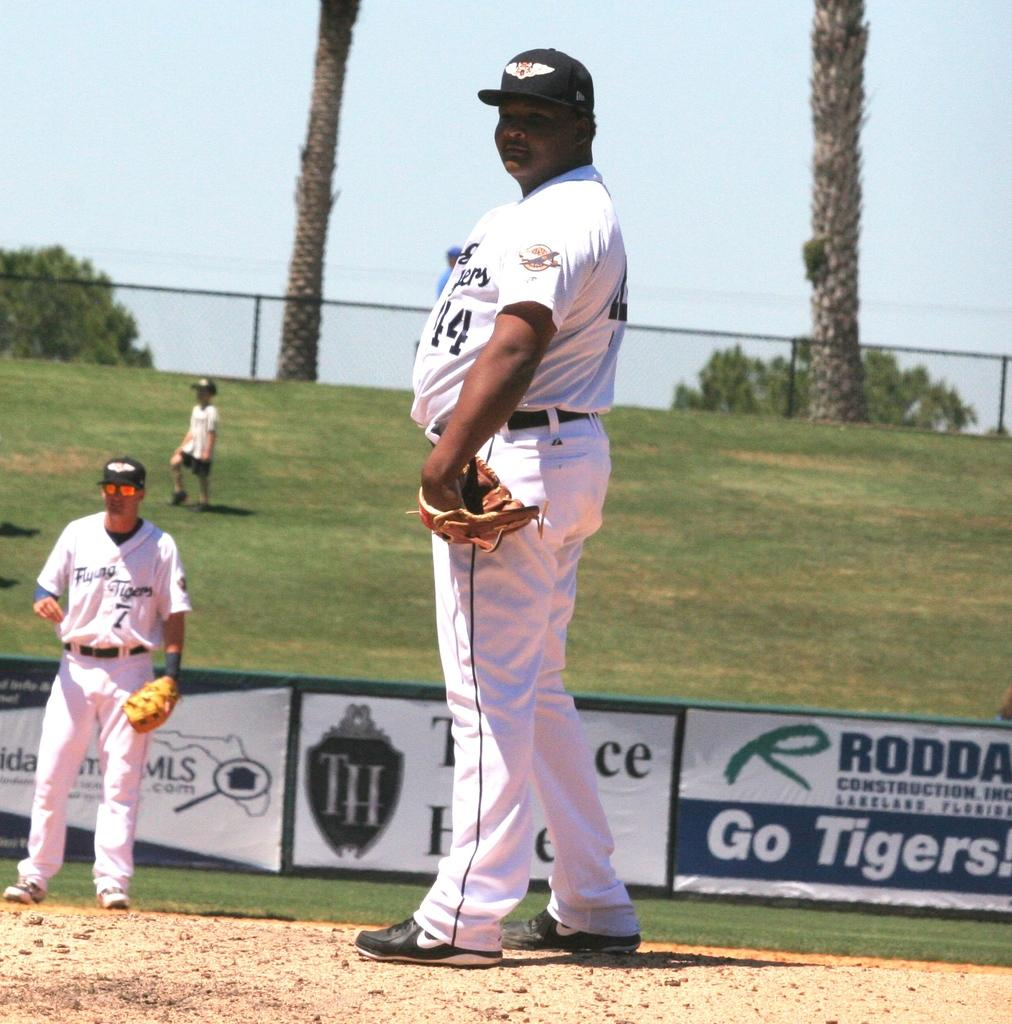<image>
Describe the image concisely. An advertisement on a baseball field urges the team on with a message of Go Tigers. 